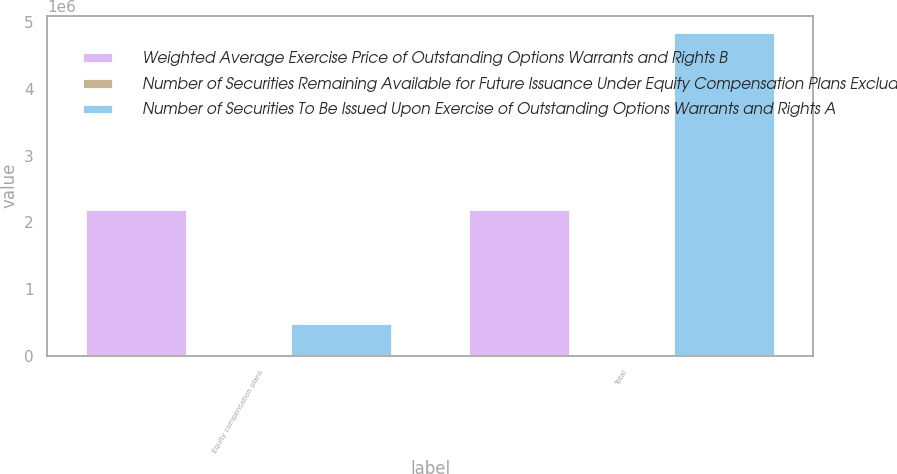<chart> <loc_0><loc_0><loc_500><loc_500><stacked_bar_chart><ecel><fcel>Equity compensation plans<fcel>Total<nl><fcel>Weighted Average Exercise Price of Outstanding Options Warrants and Rights B<fcel>2.19287e+06<fcel>2.19287e+06<nl><fcel>Number of Securities Remaining Available for Future Issuance Under Equity Compensation Plans Excluding Securities Reflected in Column A C<fcel>6.75<fcel>6.75<nl><fcel>Number of Securities To Be Issued Upon Exercise of Outstanding Options Warrants and Rights A<fcel>485360<fcel>4.8536e+06<nl></chart> 